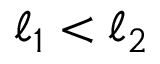<formula> <loc_0><loc_0><loc_500><loc_500>{ \ell } _ { 1 } < { \ell } _ { 2 }</formula> 